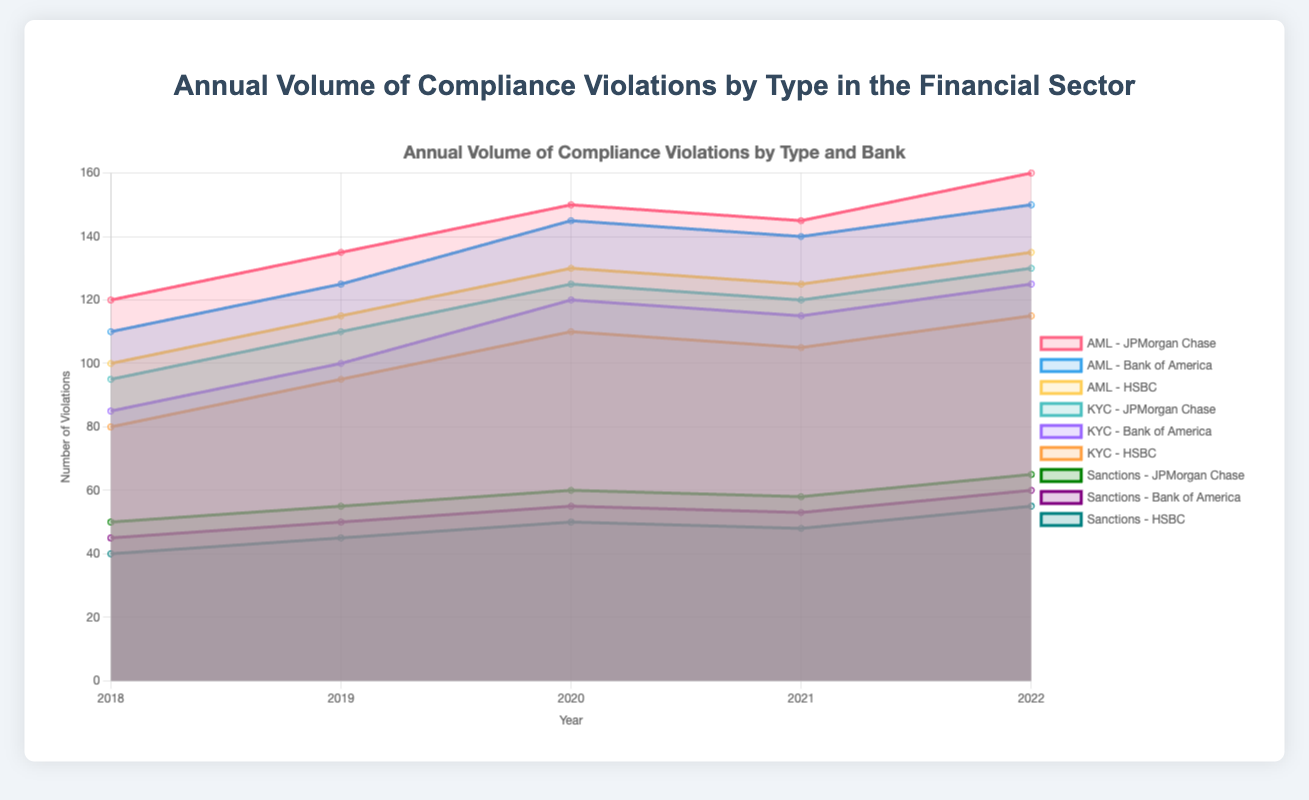What is the title of the chart? The title of the chart is displayed at the top.
Answer: Annual Volume of Compliance Violations by Type in the Financial Sector Which bank had the highest number of AML violations in 2022? Look at the year 2022 and find the highest value among the three banks' AML datasets.
Answer: JPMorgan Chase What is the trend of KYC violations for HSBC from 2018 to 2022? Follow the data points for HSBC's KYC violations from 2018 to 2022 and observe the pattern.
Answer: Increasing How many KYC violations did Bank of America have in 2020? Find the data point for Bank of America's KYC violations in the year 2020.
Answer: 120 Compare the total AML violations of all three banks in 2019. Which bank had the most, and how many more violations did it have compared to the bank with the fewest? Sum the 2019 AML violations for each bank and compare them. JPMorgan Chase: 135, Bank of America: 125, HSBC: 115. JPMorgan Chase had the most violations and had 20 more than HSBC.
Answer: JPMorgan Chase, 20 What is the average number of Sanctions violations for Bank of America from 2018 to 2022? Sum the Sanctions violations for each year and divide by the number of years (5). (45 + 50 + 55 + 53 + 60) / 5 = 52.6
Answer: 52.6 Which year had the highest total number of AML violations across all three banks? Add up the AML violations for all banks for each year and compare. 2022 has the highest sum.
Answer: 2022 What is the combined number of KYC and Sanctions violations for JPMorgan Chase in 2021? Add the numbers of KYC and Sanctions violations for JPMorgan Chase in 2021. (120 + 58)
Answer: 178 By how much did HSBC's AML violations increase from 2018 to 2022? Subtract the 2018 value from the 2022 value for HSBC's AML violations. (135 - 100)
Answer: 35 Which type of violation showed the most consistent trend over the years for Bank of America? Compare the lines for AML, KYC, and Sanctions violations for Bank of America and look for the trend with the least fluctuation.
Answer: Sanctions 